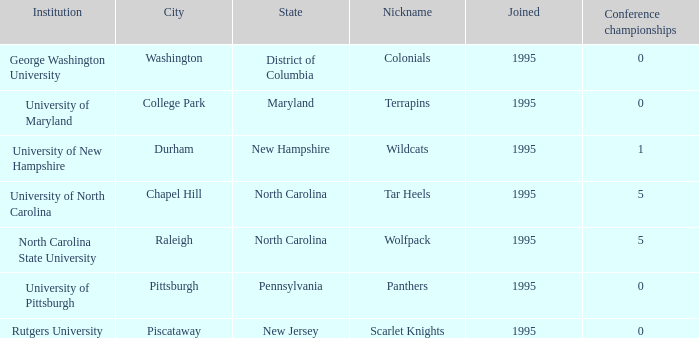What is the newest year connected to 5 conference championships at the university of north carolina institution? 1995.0. 